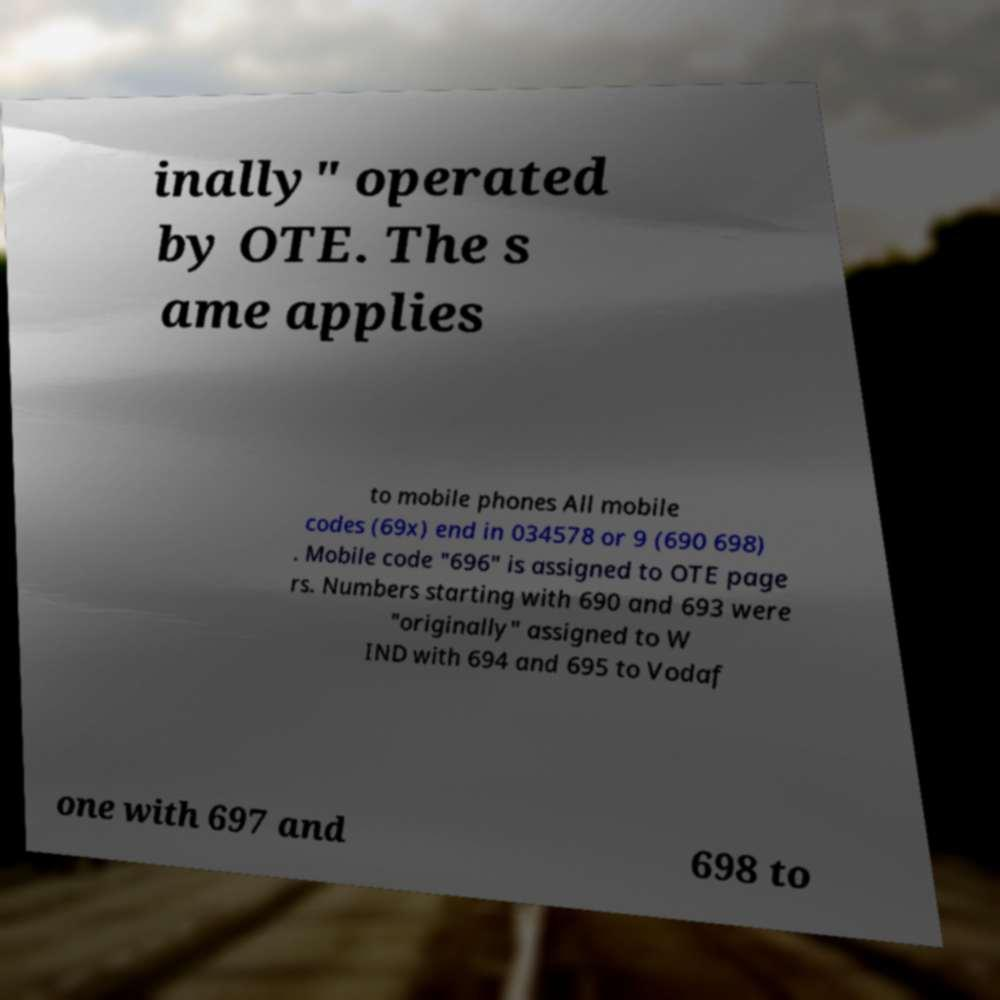Could you assist in decoding the text presented in this image and type it out clearly? inally" operated by OTE. The s ame applies to mobile phones All mobile codes (69x) end in 034578 or 9 (690 698) . Mobile code "696" is assigned to OTE page rs. Numbers starting with 690 and 693 were "originally" assigned to W IND with 694 and 695 to Vodaf one with 697 and 698 to 